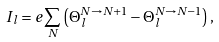Convert formula to latex. <formula><loc_0><loc_0><loc_500><loc_500>I _ { l } = e \sum _ { N } \left ( \Theta _ { l } ^ { N \to N + 1 } - \Theta _ { l } ^ { N \to N - 1 } \right ) ,</formula> 